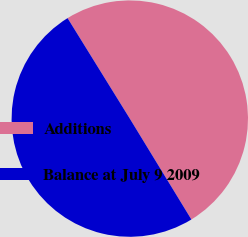<chart> <loc_0><loc_0><loc_500><loc_500><pie_chart><fcel>Additions<fcel>Balance at July 9 2009<nl><fcel>50.1%<fcel>49.9%<nl></chart> 